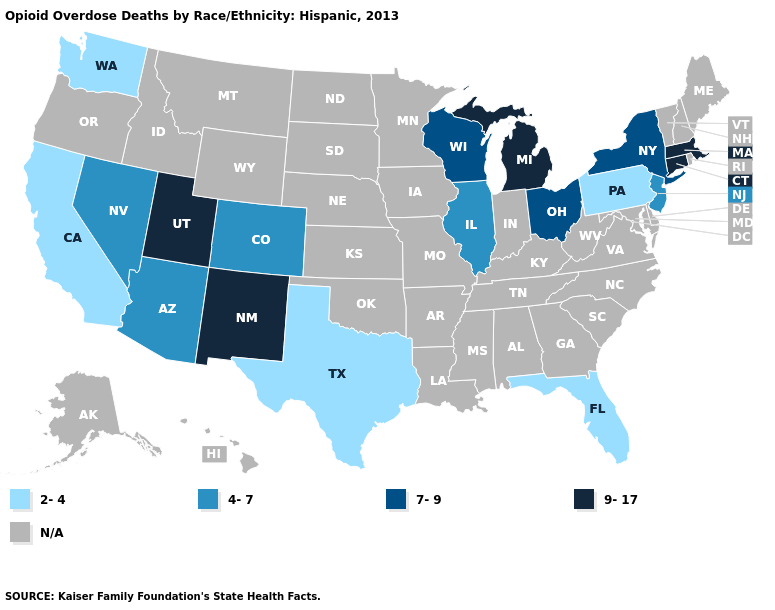What is the value of Hawaii?
Answer briefly. N/A. Name the states that have a value in the range 4-7?
Concise answer only. Arizona, Colorado, Illinois, Nevada, New Jersey. What is the value of Rhode Island?
Short answer required. N/A. Does the first symbol in the legend represent the smallest category?
Give a very brief answer. Yes. What is the lowest value in the USA?
Write a very short answer. 2-4. What is the lowest value in the Northeast?
Be succinct. 2-4. Name the states that have a value in the range 7-9?
Be succinct. New York, Ohio, Wisconsin. What is the value of Louisiana?
Write a very short answer. N/A. What is the highest value in the USA?
Give a very brief answer. 9-17. Among the states that border Idaho , which have the highest value?
Answer briefly. Utah. What is the lowest value in the South?
Keep it brief. 2-4. What is the highest value in the MidWest ?
Concise answer only. 9-17. Does Washington have the lowest value in the USA?
Be succinct. Yes. 